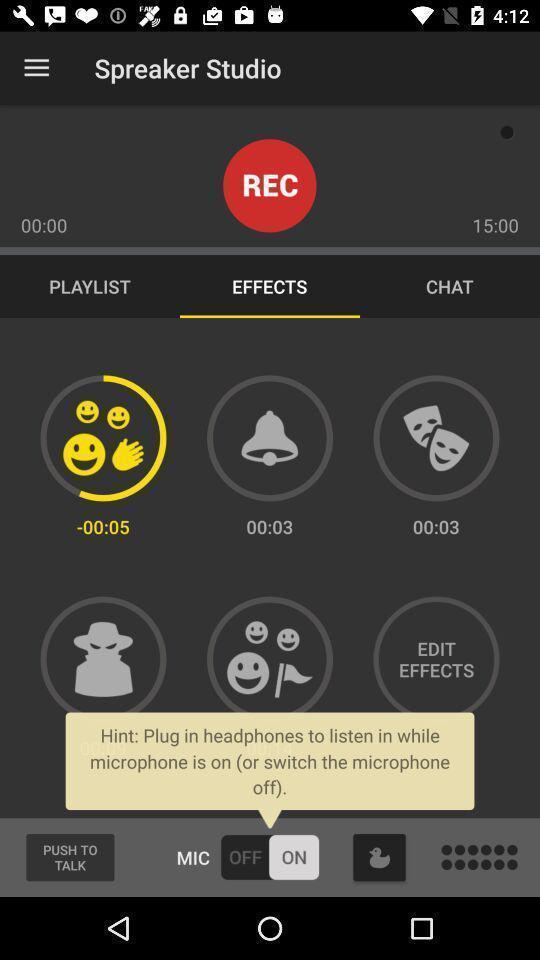Tell me about the visual elements in this screen capture. Screen shows effects of a podcast creator app. 